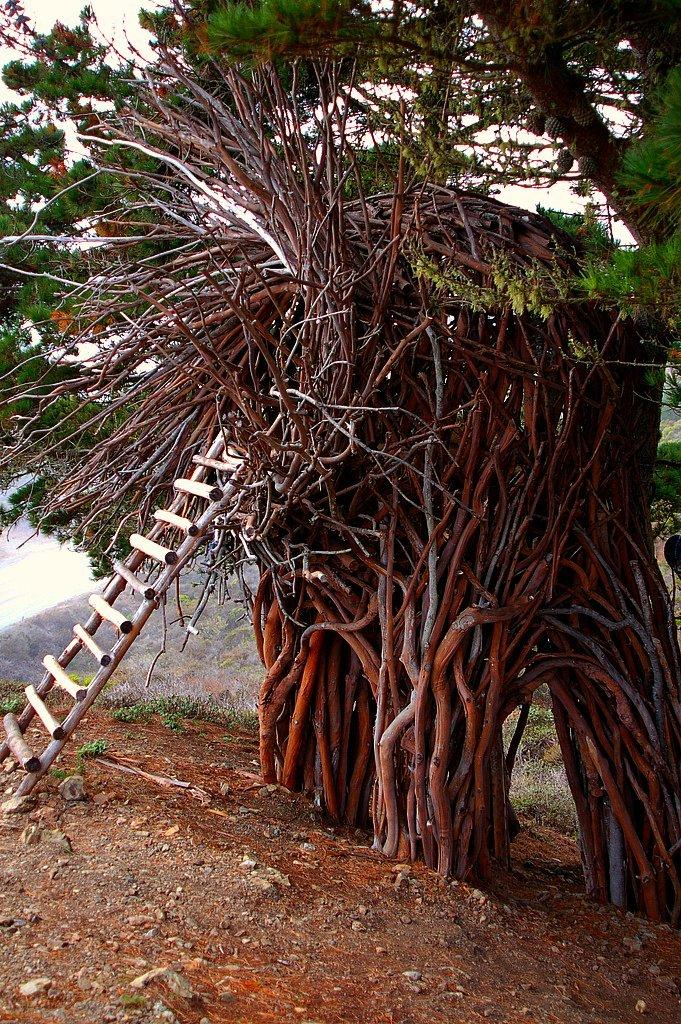What object can be seen on the left side of the image? There is a ladder in the image, and it is on the left side. What is the ladder attached to in the image? The ladder is attached to a tree in the image. Where is the tree located in the image? The tree is on the right side of the image. What type of account is being discussed in the image? There is no account being discussed in the image; it features a ladder attached to a tree. Can you see any jelly on the shelf in the image? There is no shelf or jelly present in the image. 